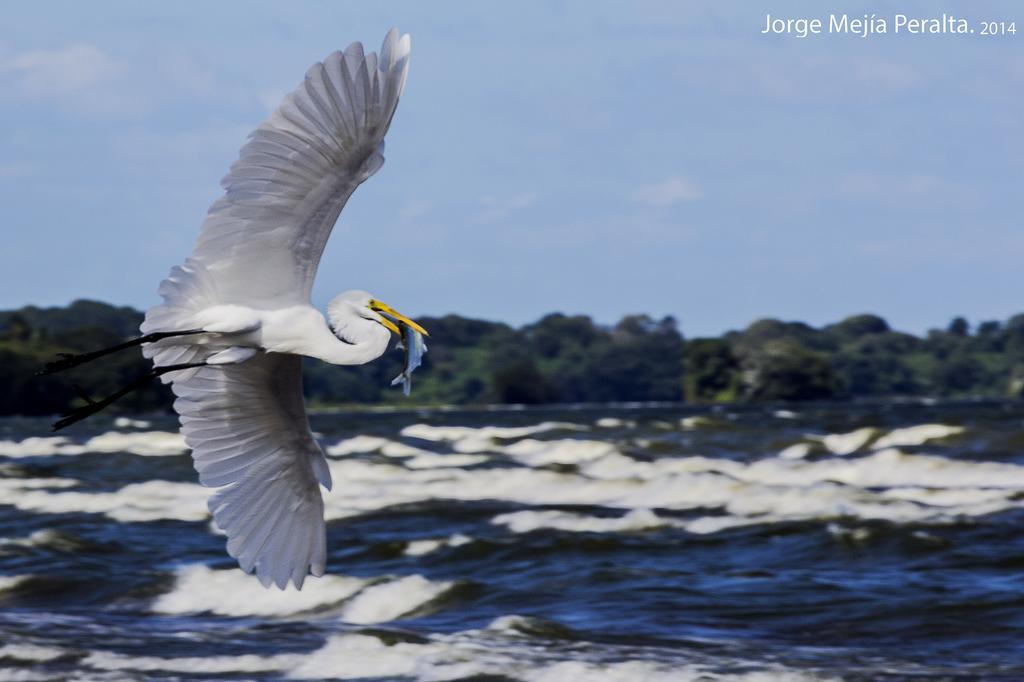In one or two sentences, can you explain what this image depicts? In this image there is crane in the air as we can see on the left side of this image. There is a sea in the bottom of this image. and there are some trees in the background,and there is a sky on the top of this image. 